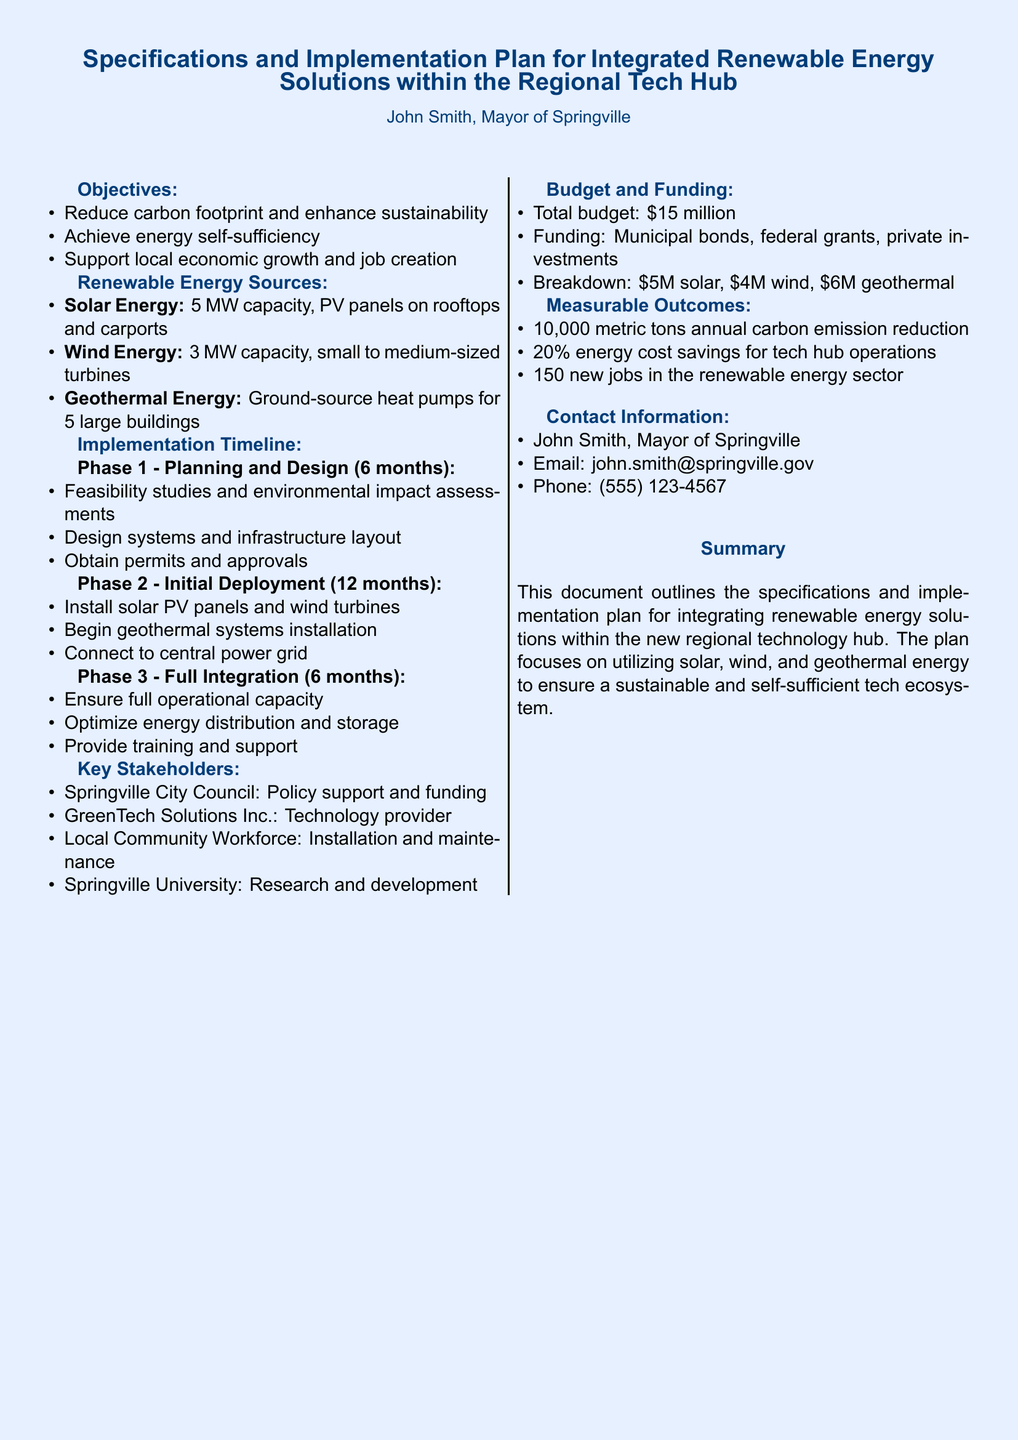what is the total budget for the project? The total budget is specified in the document under the Budget and Funding section.
Answer: $15 million what is the capacity of the solar energy solution? The capacity for solar energy is mentioned in the Renewable Energy Sources section.
Answer: 5 MW how many new jobs are expected to be created? The expected new jobs are listed in the Measurable Outcomes section.
Answer: 150 who is the technology provider for this project? The document identifies key stakeholders, including the technology provider.
Answer: GreenTech Solutions Inc what is the duration of Phase 2 in the implementation timeline? The duration for Phase 2 is outlined in the Implementation Timeline section.
Answer: 12 months how much funding is allocated for wind energy? Funding allocation for wind energy is detailed in the Budget and Funding section.
Answer: $4 million what is one of the objectives of this renewable energy project? The objectives are stated in the Objectives section of the document.
Answer: Reduce carbon footprint what phase involves connecting to the central power grid? The implementation phases specify activities, including connection to the grid.
Answer: Phase 2 - Initial Deployment what type of geothermal systems will be installed? The document specifies the type of geothermal systems under Renewable Energy Sources.
Answer: Ground-source heat pumps 